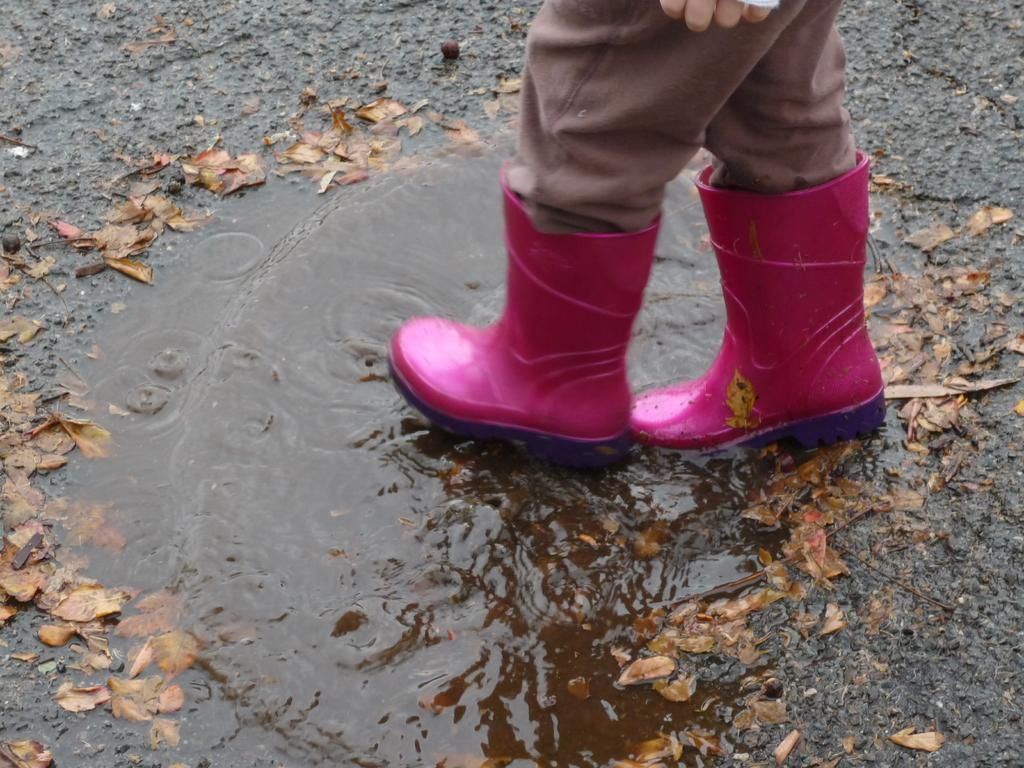What is the main subject of the image? There is a person standing in the image. What type of footwear is the person wearing? The person is wearing shoes. What can be seen at the bottom of the image? There are leaves and water visible at the bottom of the image. What type of vessel is the person holding in the image? There is no vessel present in the image. Can you describe the tail of the animal in the image? There is no animal, let alone one with a tail, present in the image. 